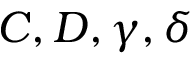Convert formula to latex. <formula><loc_0><loc_0><loc_500><loc_500>C , D , \gamma , \delta</formula> 